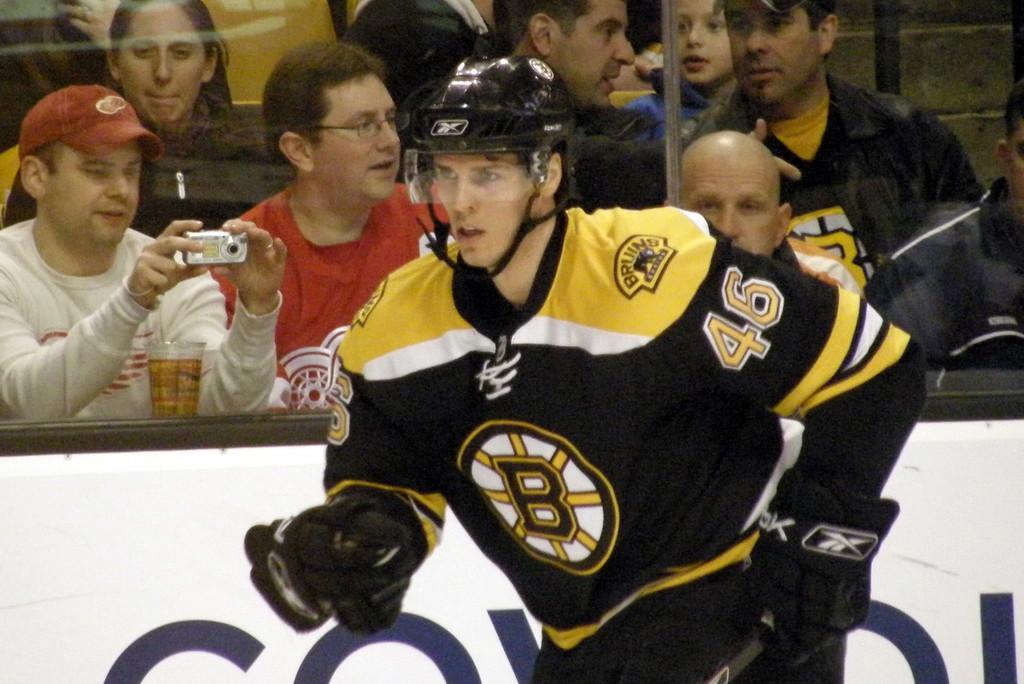What letter is embosed on the mans chest?
Provide a succinct answer. B. 